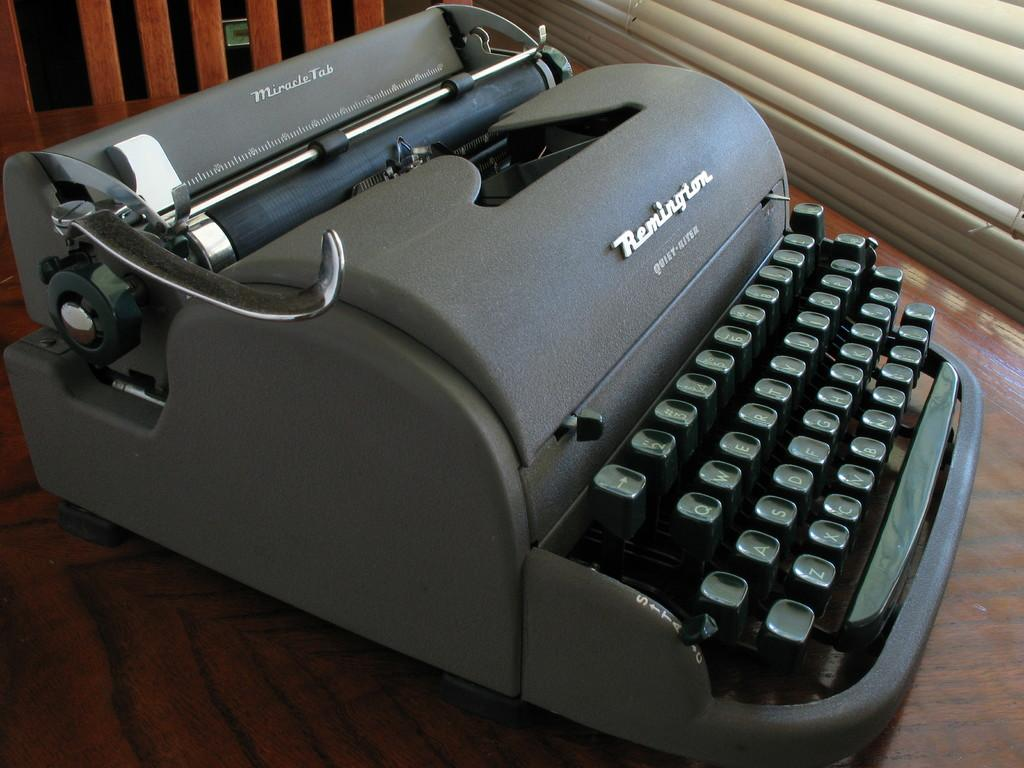What is the main object in the image? There is a typewriter in the image. On what surface is the typewriter placed? The typewriter is placed on a wooden surface. Can you describe any other elements in the image? There is a shutter in the top right corner of the image. How many pigs are visible in the image? There are no pigs present in the image. What type of trail can be seen leading up to the typewriter? There is no trail visible in the image. 